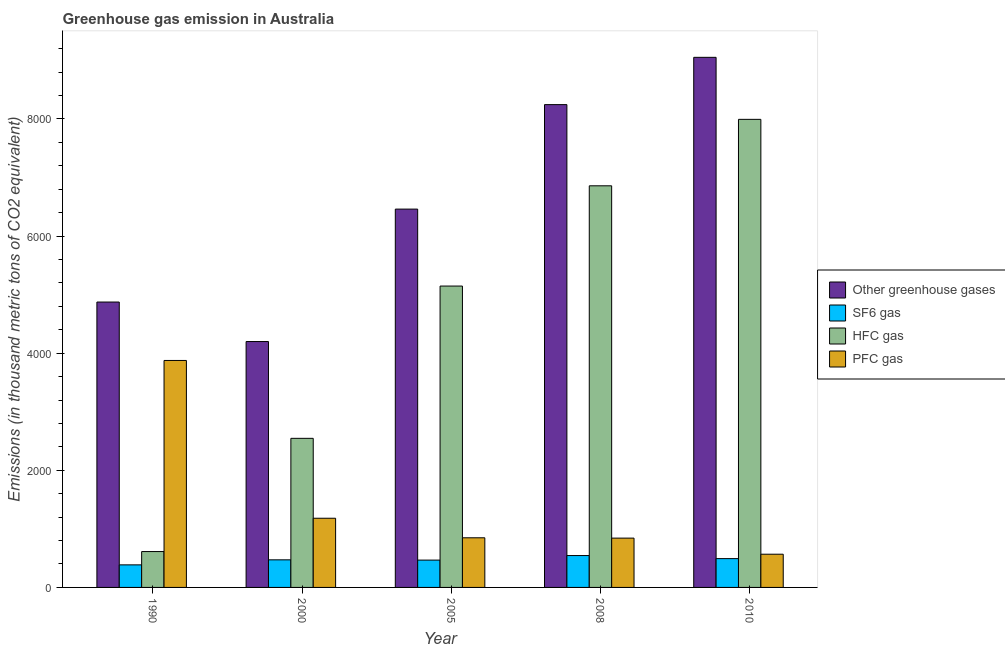How many different coloured bars are there?
Your response must be concise. 4. How many groups of bars are there?
Keep it short and to the point. 5. How many bars are there on the 2nd tick from the left?
Offer a terse response. 4. How many bars are there on the 5th tick from the right?
Your answer should be compact. 4. In how many cases, is the number of bars for a given year not equal to the number of legend labels?
Give a very brief answer. 0. What is the emission of pfc gas in 2008?
Offer a very short reply. 842. Across all years, what is the maximum emission of hfc gas?
Make the answer very short. 7992. Across all years, what is the minimum emission of hfc gas?
Your answer should be compact. 612.5. In which year was the emission of sf6 gas maximum?
Ensure brevity in your answer.  2008. In which year was the emission of sf6 gas minimum?
Provide a succinct answer. 1990. What is the total emission of sf6 gas in the graph?
Keep it short and to the point. 2359. What is the difference between the emission of pfc gas in 2005 and that in 2008?
Your answer should be compact. 5.4. What is the difference between the emission of hfc gas in 2008 and the emission of sf6 gas in 2010?
Your answer should be compact. -1134.6. What is the average emission of hfc gas per year?
Your response must be concise. 4630.64. In the year 2008, what is the difference between the emission of sf6 gas and emission of hfc gas?
Your response must be concise. 0. In how many years, is the emission of sf6 gas greater than 800 thousand metric tons?
Offer a terse response. 0. What is the ratio of the emission of sf6 gas in 1990 to that in 2008?
Give a very brief answer. 0.71. What is the difference between the highest and the second highest emission of sf6 gas?
Provide a succinct answer. 52.1. What is the difference between the highest and the lowest emission of hfc gas?
Make the answer very short. 7379.5. Is the sum of the emission of sf6 gas in 1990 and 2010 greater than the maximum emission of greenhouse gases across all years?
Your answer should be compact. Yes. What does the 4th bar from the left in 2000 represents?
Your response must be concise. PFC gas. What does the 3rd bar from the right in 2008 represents?
Provide a succinct answer. SF6 gas. How many years are there in the graph?
Offer a terse response. 5. What is the difference between two consecutive major ticks on the Y-axis?
Provide a short and direct response. 2000. Does the graph contain any zero values?
Give a very brief answer. No. Where does the legend appear in the graph?
Ensure brevity in your answer.  Center right. What is the title of the graph?
Keep it short and to the point. Greenhouse gas emission in Australia. Does "Taxes on exports" appear as one of the legend labels in the graph?
Provide a short and direct response. No. What is the label or title of the X-axis?
Ensure brevity in your answer.  Year. What is the label or title of the Y-axis?
Provide a short and direct response. Emissions (in thousand metric tons of CO2 equivalent). What is the Emissions (in thousand metric tons of CO2 equivalent) in Other greenhouse gases in 1990?
Keep it short and to the point. 4872.8. What is the Emissions (in thousand metric tons of CO2 equivalent) of SF6 gas in 1990?
Give a very brief answer. 385.1. What is the Emissions (in thousand metric tons of CO2 equivalent) of HFC gas in 1990?
Ensure brevity in your answer.  612.5. What is the Emissions (in thousand metric tons of CO2 equivalent) in PFC gas in 1990?
Provide a short and direct response. 3875.2. What is the Emissions (in thousand metric tons of CO2 equivalent) in Other greenhouse gases in 2000?
Offer a very short reply. 4198.3. What is the Emissions (in thousand metric tons of CO2 equivalent) in SF6 gas in 2000?
Provide a succinct answer. 471.2. What is the Emissions (in thousand metric tons of CO2 equivalent) of HFC gas in 2000?
Your answer should be compact. 2545.7. What is the Emissions (in thousand metric tons of CO2 equivalent) of PFC gas in 2000?
Provide a short and direct response. 1181.4. What is the Emissions (in thousand metric tons of CO2 equivalent) of Other greenhouse gases in 2005?
Provide a succinct answer. 6459.6. What is the Emissions (in thousand metric tons of CO2 equivalent) in SF6 gas in 2005?
Your answer should be very brief. 466.6. What is the Emissions (in thousand metric tons of CO2 equivalent) in HFC gas in 2005?
Ensure brevity in your answer.  5145.6. What is the Emissions (in thousand metric tons of CO2 equivalent) in PFC gas in 2005?
Your response must be concise. 847.4. What is the Emissions (in thousand metric tons of CO2 equivalent) in Other greenhouse gases in 2008?
Provide a short and direct response. 8243.5. What is the Emissions (in thousand metric tons of CO2 equivalent) in SF6 gas in 2008?
Make the answer very short. 544.1. What is the Emissions (in thousand metric tons of CO2 equivalent) in HFC gas in 2008?
Keep it short and to the point. 6857.4. What is the Emissions (in thousand metric tons of CO2 equivalent) in PFC gas in 2008?
Your answer should be very brief. 842. What is the Emissions (in thousand metric tons of CO2 equivalent) in Other greenhouse gases in 2010?
Your answer should be very brief. 9051. What is the Emissions (in thousand metric tons of CO2 equivalent) in SF6 gas in 2010?
Your answer should be compact. 492. What is the Emissions (in thousand metric tons of CO2 equivalent) of HFC gas in 2010?
Your answer should be very brief. 7992. What is the Emissions (in thousand metric tons of CO2 equivalent) of PFC gas in 2010?
Make the answer very short. 567. Across all years, what is the maximum Emissions (in thousand metric tons of CO2 equivalent) of Other greenhouse gases?
Make the answer very short. 9051. Across all years, what is the maximum Emissions (in thousand metric tons of CO2 equivalent) of SF6 gas?
Your answer should be compact. 544.1. Across all years, what is the maximum Emissions (in thousand metric tons of CO2 equivalent) of HFC gas?
Offer a terse response. 7992. Across all years, what is the maximum Emissions (in thousand metric tons of CO2 equivalent) of PFC gas?
Provide a succinct answer. 3875.2. Across all years, what is the minimum Emissions (in thousand metric tons of CO2 equivalent) in Other greenhouse gases?
Your response must be concise. 4198.3. Across all years, what is the minimum Emissions (in thousand metric tons of CO2 equivalent) in SF6 gas?
Offer a very short reply. 385.1. Across all years, what is the minimum Emissions (in thousand metric tons of CO2 equivalent) of HFC gas?
Provide a short and direct response. 612.5. Across all years, what is the minimum Emissions (in thousand metric tons of CO2 equivalent) in PFC gas?
Ensure brevity in your answer.  567. What is the total Emissions (in thousand metric tons of CO2 equivalent) of Other greenhouse gases in the graph?
Offer a terse response. 3.28e+04. What is the total Emissions (in thousand metric tons of CO2 equivalent) in SF6 gas in the graph?
Your response must be concise. 2359. What is the total Emissions (in thousand metric tons of CO2 equivalent) of HFC gas in the graph?
Provide a short and direct response. 2.32e+04. What is the total Emissions (in thousand metric tons of CO2 equivalent) in PFC gas in the graph?
Give a very brief answer. 7313. What is the difference between the Emissions (in thousand metric tons of CO2 equivalent) of Other greenhouse gases in 1990 and that in 2000?
Give a very brief answer. 674.5. What is the difference between the Emissions (in thousand metric tons of CO2 equivalent) of SF6 gas in 1990 and that in 2000?
Keep it short and to the point. -86.1. What is the difference between the Emissions (in thousand metric tons of CO2 equivalent) of HFC gas in 1990 and that in 2000?
Provide a short and direct response. -1933.2. What is the difference between the Emissions (in thousand metric tons of CO2 equivalent) in PFC gas in 1990 and that in 2000?
Provide a short and direct response. 2693.8. What is the difference between the Emissions (in thousand metric tons of CO2 equivalent) of Other greenhouse gases in 1990 and that in 2005?
Make the answer very short. -1586.8. What is the difference between the Emissions (in thousand metric tons of CO2 equivalent) in SF6 gas in 1990 and that in 2005?
Your response must be concise. -81.5. What is the difference between the Emissions (in thousand metric tons of CO2 equivalent) of HFC gas in 1990 and that in 2005?
Provide a short and direct response. -4533.1. What is the difference between the Emissions (in thousand metric tons of CO2 equivalent) of PFC gas in 1990 and that in 2005?
Provide a short and direct response. 3027.8. What is the difference between the Emissions (in thousand metric tons of CO2 equivalent) of Other greenhouse gases in 1990 and that in 2008?
Your answer should be very brief. -3370.7. What is the difference between the Emissions (in thousand metric tons of CO2 equivalent) in SF6 gas in 1990 and that in 2008?
Your answer should be very brief. -159. What is the difference between the Emissions (in thousand metric tons of CO2 equivalent) in HFC gas in 1990 and that in 2008?
Provide a succinct answer. -6244.9. What is the difference between the Emissions (in thousand metric tons of CO2 equivalent) in PFC gas in 1990 and that in 2008?
Make the answer very short. 3033.2. What is the difference between the Emissions (in thousand metric tons of CO2 equivalent) of Other greenhouse gases in 1990 and that in 2010?
Provide a short and direct response. -4178.2. What is the difference between the Emissions (in thousand metric tons of CO2 equivalent) in SF6 gas in 1990 and that in 2010?
Your answer should be very brief. -106.9. What is the difference between the Emissions (in thousand metric tons of CO2 equivalent) of HFC gas in 1990 and that in 2010?
Ensure brevity in your answer.  -7379.5. What is the difference between the Emissions (in thousand metric tons of CO2 equivalent) in PFC gas in 1990 and that in 2010?
Ensure brevity in your answer.  3308.2. What is the difference between the Emissions (in thousand metric tons of CO2 equivalent) of Other greenhouse gases in 2000 and that in 2005?
Give a very brief answer. -2261.3. What is the difference between the Emissions (in thousand metric tons of CO2 equivalent) in SF6 gas in 2000 and that in 2005?
Make the answer very short. 4.6. What is the difference between the Emissions (in thousand metric tons of CO2 equivalent) of HFC gas in 2000 and that in 2005?
Give a very brief answer. -2599.9. What is the difference between the Emissions (in thousand metric tons of CO2 equivalent) of PFC gas in 2000 and that in 2005?
Give a very brief answer. 334. What is the difference between the Emissions (in thousand metric tons of CO2 equivalent) of Other greenhouse gases in 2000 and that in 2008?
Your response must be concise. -4045.2. What is the difference between the Emissions (in thousand metric tons of CO2 equivalent) in SF6 gas in 2000 and that in 2008?
Make the answer very short. -72.9. What is the difference between the Emissions (in thousand metric tons of CO2 equivalent) in HFC gas in 2000 and that in 2008?
Ensure brevity in your answer.  -4311.7. What is the difference between the Emissions (in thousand metric tons of CO2 equivalent) of PFC gas in 2000 and that in 2008?
Provide a succinct answer. 339.4. What is the difference between the Emissions (in thousand metric tons of CO2 equivalent) in Other greenhouse gases in 2000 and that in 2010?
Provide a short and direct response. -4852.7. What is the difference between the Emissions (in thousand metric tons of CO2 equivalent) in SF6 gas in 2000 and that in 2010?
Your answer should be compact. -20.8. What is the difference between the Emissions (in thousand metric tons of CO2 equivalent) of HFC gas in 2000 and that in 2010?
Your answer should be compact. -5446.3. What is the difference between the Emissions (in thousand metric tons of CO2 equivalent) in PFC gas in 2000 and that in 2010?
Give a very brief answer. 614.4. What is the difference between the Emissions (in thousand metric tons of CO2 equivalent) in Other greenhouse gases in 2005 and that in 2008?
Offer a very short reply. -1783.9. What is the difference between the Emissions (in thousand metric tons of CO2 equivalent) of SF6 gas in 2005 and that in 2008?
Offer a terse response. -77.5. What is the difference between the Emissions (in thousand metric tons of CO2 equivalent) in HFC gas in 2005 and that in 2008?
Keep it short and to the point. -1711.8. What is the difference between the Emissions (in thousand metric tons of CO2 equivalent) in PFC gas in 2005 and that in 2008?
Keep it short and to the point. 5.4. What is the difference between the Emissions (in thousand metric tons of CO2 equivalent) of Other greenhouse gases in 2005 and that in 2010?
Your answer should be very brief. -2591.4. What is the difference between the Emissions (in thousand metric tons of CO2 equivalent) in SF6 gas in 2005 and that in 2010?
Keep it short and to the point. -25.4. What is the difference between the Emissions (in thousand metric tons of CO2 equivalent) in HFC gas in 2005 and that in 2010?
Provide a short and direct response. -2846.4. What is the difference between the Emissions (in thousand metric tons of CO2 equivalent) in PFC gas in 2005 and that in 2010?
Make the answer very short. 280.4. What is the difference between the Emissions (in thousand metric tons of CO2 equivalent) of Other greenhouse gases in 2008 and that in 2010?
Provide a short and direct response. -807.5. What is the difference between the Emissions (in thousand metric tons of CO2 equivalent) in SF6 gas in 2008 and that in 2010?
Offer a terse response. 52.1. What is the difference between the Emissions (in thousand metric tons of CO2 equivalent) in HFC gas in 2008 and that in 2010?
Provide a short and direct response. -1134.6. What is the difference between the Emissions (in thousand metric tons of CO2 equivalent) in PFC gas in 2008 and that in 2010?
Offer a terse response. 275. What is the difference between the Emissions (in thousand metric tons of CO2 equivalent) of Other greenhouse gases in 1990 and the Emissions (in thousand metric tons of CO2 equivalent) of SF6 gas in 2000?
Provide a short and direct response. 4401.6. What is the difference between the Emissions (in thousand metric tons of CO2 equivalent) in Other greenhouse gases in 1990 and the Emissions (in thousand metric tons of CO2 equivalent) in HFC gas in 2000?
Your response must be concise. 2327.1. What is the difference between the Emissions (in thousand metric tons of CO2 equivalent) in Other greenhouse gases in 1990 and the Emissions (in thousand metric tons of CO2 equivalent) in PFC gas in 2000?
Your answer should be compact. 3691.4. What is the difference between the Emissions (in thousand metric tons of CO2 equivalent) of SF6 gas in 1990 and the Emissions (in thousand metric tons of CO2 equivalent) of HFC gas in 2000?
Your answer should be very brief. -2160.6. What is the difference between the Emissions (in thousand metric tons of CO2 equivalent) in SF6 gas in 1990 and the Emissions (in thousand metric tons of CO2 equivalent) in PFC gas in 2000?
Ensure brevity in your answer.  -796.3. What is the difference between the Emissions (in thousand metric tons of CO2 equivalent) in HFC gas in 1990 and the Emissions (in thousand metric tons of CO2 equivalent) in PFC gas in 2000?
Your answer should be compact. -568.9. What is the difference between the Emissions (in thousand metric tons of CO2 equivalent) of Other greenhouse gases in 1990 and the Emissions (in thousand metric tons of CO2 equivalent) of SF6 gas in 2005?
Make the answer very short. 4406.2. What is the difference between the Emissions (in thousand metric tons of CO2 equivalent) in Other greenhouse gases in 1990 and the Emissions (in thousand metric tons of CO2 equivalent) in HFC gas in 2005?
Give a very brief answer. -272.8. What is the difference between the Emissions (in thousand metric tons of CO2 equivalent) in Other greenhouse gases in 1990 and the Emissions (in thousand metric tons of CO2 equivalent) in PFC gas in 2005?
Your answer should be very brief. 4025.4. What is the difference between the Emissions (in thousand metric tons of CO2 equivalent) of SF6 gas in 1990 and the Emissions (in thousand metric tons of CO2 equivalent) of HFC gas in 2005?
Give a very brief answer. -4760.5. What is the difference between the Emissions (in thousand metric tons of CO2 equivalent) in SF6 gas in 1990 and the Emissions (in thousand metric tons of CO2 equivalent) in PFC gas in 2005?
Ensure brevity in your answer.  -462.3. What is the difference between the Emissions (in thousand metric tons of CO2 equivalent) in HFC gas in 1990 and the Emissions (in thousand metric tons of CO2 equivalent) in PFC gas in 2005?
Offer a very short reply. -234.9. What is the difference between the Emissions (in thousand metric tons of CO2 equivalent) of Other greenhouse gases in 1990 and the Emissions (in thousand metric tons of CO2 equivalent) of SF6 gas in 2008?
Provide a succinct answer. 4328.7. What is the difference between the Emissions (in thousand metric tons of CO2 equivalent) of Other greenhouse gases in 1990 and the Emissions (in thousand metric tons of CO2 equivalent) of HFC gas in 2008?
Your response must be concise. -1984.6. What is the difference between the Emissions (in thousand metric tons of CO2 equivalent) of Other greenhouse gases in 1990 and the Emissions (in thousand metric tons of CO2 equivalent) of PFC gas in 2008?
Keep it short and to the point. 4030.8. What is the difference between the Emissions (in thousand metric tons of CO2 equivalent) of SF6 gas in 1990 and the Emissions (in thousand metric tons of CO2 equivalent) of HFC gas in 2008?
Your response must be concise. -6472.3. What is the difference between the Emissions (in thousand metric tons of CO2 equivalent) of SF6 gas in 1990 and the Emissions (in thousand metric tons of CO2 equivalent) of PFC gas in 2008?
Give a very brief answer. -456.9. What is the difference between the Emissions (in thousand metric tons of CO2 equivalent) of HFC gas in 1990 and the Emissions (in thousand metric tons of CO2 equivalent) of PFC gas in 2008?
Offer a terse response. -229.5. What is the difference between the Emissions (in thousand metric tons of CO2 equivalent) of Other greenhouse gases in 1990 and the Emissions (in thousand metric tons of CO2 equivalent) of SF6 gas in 2010?
Ensure brevity in your answer.  4380.8. What is the difference between the Emissions (in thousand metric tons of CO2 equivalent) of Other greenhouse gases in 1990 and the Emissions (in thousand metric tons of CO2 equivalent) of HFC gas in 2010?
Provide a short and direct response. -3119.2. What is the difference between the Emissions (in thousand metric tons of CO2 equivalent) in Other greenhouse gases in 1990 and the Emissions (in thousand metric tons of CO2 equivalent) in PFC gas in 2010?
Keep it short and to the point. 4305.8. What is the difference between the Emissions (in thousand metric tons of CO2 equivalent) in SF6 gas in 1990 and the Emissions (in thousand metric tons of CO2 equivalent) in HFC gas in 2010?
Provide a short and direct response. -7606.9. What is the difference between the Emissions (in thousand metric tons of CO2 equivalent) of SF6 gas in 1990 and the Emissions (in thousand metric tons of CO2 equivalent) of PFC gas in 2010?
Your response must be concise. -181.9. What is the difference between the Emissions (in thousand metric tons of CO2 equivalent) of HFC gas in 1990 and the Emissions (in thousand metric tons of CO2 equivalent) of PFC gas in 2010?
Your answer should be very brief. 45.5. What is the difference between the Emissions (in thousand metric tons of CO2 equivalent) of Other greenhouse gases in 2000 and the Emissions (in thousand metric tons of CO2 equivalent) of SF6 gas in 2005?
Give a very brief answer. 3731.7. What is the difference between the Emissions (in thousand metric tons of CO2 equivalent) of Other greenhouse gases in 2000 and the Emissions (in thousand metric tons of CO2 equivalent) of HFC gas in 2005?
Offer a terse response. -947.3. What is the difference between the Emissions (in thousand metric tons of CO2 equivalent) in Other greenhouse gases in 2000 and the Emissions (in thousand metric tons of CO2 equivalent) in PFC gas in 2005?
Make the answer very short. 3350.9. What is the difference between the Emissions (in thousand metric tons of CO2 equivalent) of SF6 gas in 2000 and the Emissions (in thousand metric tons of CO2 equivalent) of HFC gas in 2005?
Your answer should be compact. -4674.4. What is the difference between the Emissions (in thousand metric tons of CO2 equivalent) in SF6 gas in 2000 and the Emissions (in thousand metric tons of CO2 equivalent) in PFC gas in 2005?
Ensure brevity in your answer.  -376.2. What is the difference between the Emissions (in thousand metric tons of CO2 equivalent) of HFC gas in 2000 and the Emissions (in thousand metric tons of CO2 equivalent) of PFC gas in 2005?
Offer a terse response. 1698.3. What is the difference between the Emissions (in thousand metric tons of CO2 equivalent) in Other greenhouse gases in 2000 and the Emissions (in thousand metric tons of CO2 equivalent) in SF6 gas in 2008?
Offer a very short reply. 3654.2. What is the difference between the Emissions (in thousand metric tons of CO2 equivalent) in Other greenhouse gases in 2000 and the Emissions (in thousand metric tons of CO2 equivalent) in HFC gas in 2008?
Offer a terse response. -2659.1. What is the difference between the Emissions (in thousand metric tons of CO2 equivalent) in Other greenhouse gases in 2000 and the Emissions (in thousand metric tons of CO2 equivalent) in PFC gas in 2008?
Make the answer very short. 3356.3. What is the difference between the Emissions (in thousand metric tons of CO2 equivalent) in SF6 gas in 2000 and the Emissions (in thousand metric tons of CO2 equivalent) in HFC gas in 2008?
Make the answer very short. -6386.2. What is the difference between the Emissions (in thousand metric tons of CO2 equivalent) in SF6 gas in 2000 and the Emissions (in thousand metric tons of CO2 equivalent) in PFC gas in 2008?
Your response must be concise. -370.8. What is the difference between the Emissions (in thousand metric tons of CO2 equivalent) of HFC gas in 2000 and the Emissions (in thousand metric tons of CO2 equivalent) of PFC gas in 2008?
Your answer should be very brief. 1703.7. What is the difference between the Emissions (in thousand metric tons of CO2 equivalent) in Other greenhouse gases in 2000 and the Emissions (in thousand metric tons of CO2 equivalent) in SF6 gas in 2010?
Give a very brief answer. 3706.3. What is the difference between the Emissions (in thousand metric tons of CO2 equivalent) in Other greenhouse gases in 2000 and the Emissions (in thousand metric tons of CO2 equivalent) in HFC gas in 2010?
Ensure brevity in your answer.  -3793.7. What is the difference between the Emissions (in thousand metric tons of CO2 equivalent) of Other greenhouse gases in 2000 and the Emissions (in thousand metric tons of CO2 equivalent) of PFC gas in 2010?
Provide a succinct answer. 3631.3. What is the difference between the Emissions (in thousand metric tons of CO2 equivalent) in SF6 gas in 2000 and the Emissions (in thousand metric tons of CO2 equivalent) in HFC gas in 2010?
Your answer should be compact. -7520.8. What is the difference between the Emissions (in thousand metric tons of CO2 equivalent) in SF6 gas in 2000 and the Emissions (in thousand metric tons of CO2 equivalent) in PFC gas in 2010?
Offer a terse response. -95.8. What is the difference between the Emissions (in thousand metric tons of CO2 equivalent) in HFC gas in 2000 and the Emissions (in thousand metric tons of CO2 equivalent) in PFC gas in 2010?
Your answer should be very brief. 1978.7. What is the difference between the Emissions (in thousand metric tons of CO2 equivalent) of Other greenhouse gases in 2005 and the Emissions (in thousand metric tons of CO2 equivalent) of SF6 gas in 2008?
Provide a succinct answer. 5915.5. What is the difference between the Emissions (in thousand metric tons of CO2 equivalent) of Other greenhouse gases in 2005 and the Emissions (in thousand metric tons of CO2 equivalent) of HFC gas in 2008?
Provide a short and direct response. -397.8. What is the difference between the Emissions (in thousand metric tons of CO2 equivalent) in Other greenhouse gases in 2005 and the Emissions (in thousand metric tons of CO2 equivalent) in PFC gas in 2008?
Provide a succinct answer. 5617.6. What is the difference between the Emissions (in thousand metric tons of CO2 equivalent) in SF6 gas in 2005 and the Emissions (in thousand metric tons of CO2 equivalent) in HFC gas in 2008?
Provide a succinct answer. -6390.8. What is the difference between the Emissions (in thousand metric tons of CO2 equivalent) in SF6 gas in 2005 and the Emissions (in thousand metric tons of CO2 equivalent) in PFC gas in 2008?
Offer a terse response. -375.4. What is the difference between the Emissions (in thousand metric tons of CO2 equivalent) in HFC gas in 2005 and the Emissions (in thousand metric tons of CO2 equivalent) in PFC gas in 2008?
Make the answer very short. 4303.6. What is the difference between the Emissions (in thousand metric tons of CO2 equivalent) of Other greenhouse gases in 2005 and the Emissions (in thousand metric tons of CO2 equivalent) of SF6 gas in 2010?
Ensure brevity in your answer.  5967.6. What is the difference between the Emissions (in thousand metric tons of CO2 equivalent) in Other greenhouse gases in 2005 and the Emissions (in thousand metric tons of CO2 equivalent) in HFC gas in 2010?
Offer a very short reply. -1532.4. What is the difference between the Emissions (in thousand metric tons of CO2 equivalent) in Other greenhouse gases in 2005 and the Emissions (in thousand metric tons of CO2 equivalent) in PFC gas in 2010?
Give a very brief answer. 5892.6. What is the difference between the Emissions (in thousand metric tons of CO2 equivalent) in SF6 gas in 2005 and the Emissions (in thousand metric tons of CO2 equivalent) in HFC gas in 2010?
Make the answer very short. -7525.4. What is the difference between the Emissions (in thousand metric tons of CO2 equivalent) of SF6 gas in 2005 and the Emissions (in thousand metric tons of CO2 equivalent) of PFC gas in 2010?
Provide a succinct answer. -100.4. What is the difference between the Emissions (in thousand metric tons of CO2 equivalent) in HFC gas in 2005 and the Emissions (in thousand metric tons of CO2 equivalent) in PFC gas in 2010?
Offer a very short reply. 4578.6. What is the difference between the Emissions (in thousand metric tons of CO2 equivalent) of Other greenhouse gases in 2008 and the Emissions (in thousand metric tons of CO2 equivalent) of SF6 gas in 2010?
Your answer should be very brief. 7751.5. What is the difference between the Emissions (in thousand metric tons of CO2 equivalent) in Other greenhouse gases in 2008 and the Emissions (in thousand metric tons of CO2 equivalent) in HFC gas in 2010?
Offer a very short reply. 251.5. What is the difference between the Emissions (in thousand metric tons of CO2 equivalent) in Other greenhouse gases in 2008 and the Emissions (in thousand metric tons of CO2 equivalent) in PFC gas in 2010?
Keep it short and to the point. 7676.5. What is the difference between the Emissions (in thousand metric tons of CO2 equivalent) in SF6 gas in 2008 and the Emissions (in thousand metric tons of CO2 equivalent) in HFC gas in 2010?
Your answer should be compact. -7447.9. What is the difference between the Emissions (in thousand metric tons of CO2 equivalent) of SF6 gas in 2008 and the Emissions (in thousand metric tons of CO2 equivalent) of PFC gas in 2010?
Ensure brevity in your answer.  -22.9. What is the difference between the Emissions (in thousand metric tons of CO2 equivalent) in HFC gas in 2008 and the Emissions (in thousand metric tons of CO2 equivalent) in PFC gas in 2010?
Your answer should be compact. 6290.4. What is the average Emissions (in thousand metric tons of CO2 equivalent) in Other greenhouse gases per year?
Give a very brief answer. 6565.04. What is the average Emissions (in thousand metric tons of CO2 equivalent) of SF6 gas per year?
Give a very brief answer. 471.8. What is the average Emissions (in thousand metric tons of CO2 equivalent) of HFC gas per year?
Give a very brief answer. 4630.64. What is the average Emissions (in thousand metric tons of CO2 equivalent) of PFC gas per year?
Offer a very short reply. 1462.6. In the year 1990, what is the difference between the Emissions (in thousand metric tons of CO2 equivalent) of Other greenhouse gases and Emissions (in thousand metric tons of CO2 equivalent) of SF6 gas?
Offer a very short reply. 4487.7. In the year 1990, what is the difference between the Emissions (in thousand metric tons of CO2 equivalent) in Other greenhouse gases and Emissions (in thousand metric tons of CO2 equivalent) in HFC gas?
Give a very brief answer. 4260.3. In the year 1990, what is the difference between the Emissions (in thousand metric tons of CO2 equivalent) of Other greenhouse gases and Emissions (in thousand metric tons of CO2 equivalent) of PFC gas?
Offer a terse response. 997.6. In the year 1990, what is the difference between the Emissions (in thousand metric tons of CO2 equivalent) of SF6 gas and Emissions (in thousand metric tons of CO2 equivalent) of HFC gas?
Give a very brief answer. -227.4. In the year 1990, what is the difference between the Emissions (in thousand metric tons of CO2 equivalent) in SF6 gas and Emissions (in thousand metric tons of CO2 equivalent) in PFC gas?
Ensure brevity in your answer.  -3490.1. In the year 1990, what is the difference between the Emissions (in thousand metric tons of CO2 equivalent) of HFC gas and Emissions (in thousand metric tons of CO2 equivalent) of PFC gas?
Provide a short and direct response. -3262.7. In the year 2000, what is the difference between the Emissions (in thousand metric tons of CO2 equivalent) in Other greenhouse gases and Emissions (in thousand metric tons of CO2 equivalent) in SF6 gas?
Keep it short and to the point. 3727.1. In the year 2000, what is the difference between the Emissions (in thousand metric tons of CO2 equivalent) of Other greenhouse gases and Emissions (in thousand metric tons of CO2 equivalent) of HFC gas?
Provide a short and direct response. 1652.6. In the year 2000, what is the difference between the Emissions (in thousand metric tons of CO2 equivalent) of Other greenhouse gases and Emissions (in thousand metric tons of CO2 equivalent) of PFC gas?
Make the answer very short. 3016.9. In the year 2000, what is the difference between the Emissions (in thousand metric tons of CO2 equivalent) of SF6 gas and Emissions (in thousand metric tons of CO2 equivalent) of HFC gas?
Offer a very short reply. -2074.5. In the year 2000, what is the difference between the Emissions (in thousand metric tons of CO2 equivalent) in SF6 gas and Emissions (in thousand metric tons of CO2 equivalent) in PFC gas?
Your answer should be very brief. -710.2. In the year 2000, what is the difference between the Emissions (in thousand metric tons of CO2 equivalent) of HFC gas and Emissions (in thousand metric tons of CO2 equivalent) of PFC gas?
Offer a very short reply. 1364.3. In the year 2005, what is the difference between the Emissions (in thousand metric tons of CO2 equivalent) in Other greenhouse gases and Emissions (in thousand metric tons of CO2 equivalent) in SF6 gas?
Provide a short and direct response. 5993. In the year 2005, what is the difference between the Emissions (in thousand metric tons of CO2 equivalent) in Other greenhouse gases and Emissions (in thousand metric tons of CO2 equivalent) in HFC gas?
Keep it short and to the point. 1314. In the year 2005, what is the difference between the Emissions (in thousand metric tons of CO2 equivalent) in Other greenhouse gases and Emissions (in thousand metric tons of CO2 equivalent) in PFC gas?
Provide a short and direct response. 5612.2. In the year 2005, what is the difference between the Emissions (in thousand metric tons of CO2 equivalent) in SF6 gas and Emissions (in thousand metric tons of CO2 equivalent) in HFC gas?
Offer a terse response. -4679. In the year 2005, what is the difference between the Emissions (in thousand metric tons of CO2 equivalent) in SF6 gas and Emissions (in thousand metric tons of CO2 equivalent) in PFC gas?
Offer a very short reply. -380.8. In the year 2005, what is the difference between the Emissions (in thousand metric tons of CO2 equivalent) in HFC gas and Emissions (in thousand metric tons of CO2 equivalent) in PFC gas?
Ensure brevity in your answer.  4298.2. In the year 2008, what is the difference between the Emissions (in thousand metric tons of CO2 equivalent) of Other greenhouse gases and Emissions (in thousand metric tons of CO2 equivalent) of SF6 gas?
Ensure brevity in your answer.  7699.4. In the year 2008, what is the difference between the Emissions (in thousand metric tons of CO2 equivalent) of Other greenhouse gases and Emissions (in thousand metric tons of CO2 equivalent) of HFC gas?
Offer a terse response. 1386.1. In the year 2008, what is the difference between the Emissions (in thousand metric tons of CO2 equivalent) in Other greenhouse gases and Emissions (in thousand metric tons of CO2 equivalent) in PFC gas?
Offer a terse response. 7401.5. In the year 2008, what is the difference between the Emissions (in thousand metric tons of CO2 equivalent) of SF6 gas and Emissions (in thousand metric tons of CO2 equivalent) of HFC gas?
Ensure brevity in your answer.  -6313.3. In the year 2008, what is the difference between the Emissions (in thousand metric tons of CO2 equivalent) of SF6 gas and Emissions (in thousand metric tons of CO2 equivalent) of PFC gas?
Give a very brief answer. -297.9. In the year 2008, what is the difference between the Emissions (in thousand metric tons of CO2 equivalent) of HFC gas and Emissions (in thousand metric tons of CO2 equivalent) of PFC gas?
Give a very brief answer. 6015.4. In the year 2010, what is the difference between the Emissions (in thousand metric tons of CO2 equivalent) of Other greenhouse gases and Emissions (in thousand metric tons of CO2 equivalent) of SF6 gas?
Keep it short and to the point. 8559. In the year 2010, what is the difference between the Emissions (in thousand metric tons of CO2 equivalent) in Other greenhouse gases and Emissions (in thousand metric tons of CO2 equivalent) in HFC gas?
Provide a succinct answer. 1059. In the year 2010, what is the difference between the Emissions (in thousand metric tons of CO2 equivalent) of Other greenhouse gases and Emissions (in thousand metric tons of CO2 equivalent) of PFC gas?
Offer a terse response. 8484. In the year 2010, what is the difference between the Emissions (in thousand metric tons of CO2 equivalent) of SF6 gas and Emissions (in thousand metric tons of CO2 equivalent) of HFC gas?
Offer a very short reply. -7500. In the year 2010, what is the difference between the Emissions (in thousand metric tons of CO2 equivalent) of SF6 gas and Emissions (in thousand metric tons of CO2 equivalent) of PFC gas?
Ensure brevity in your answer.  -75. In the year 2010, what is the difference between the Emissions (in thousand metric tons of CO2 equivalent) of HFC gas and Emissions (in thousand metric tons of CO2 equivalent) of PFC gas?
Offer a terse response. 7425. What is the ratio of the Emissions (in thousand metric tons of CO2 equivalent) of Other greenhouse gases in 1990 to that in 2000?
Make the answer very short. 1.16. What is the ratio of the Emissions (in thousand metric tons of CO2 equivalent) in SF6 gas in 1990 to that in 2000?
Your answer should be very brief. 0.82. What is the ratio of the Emissions (in thousand metric tons of CO2 equivalent) in HFC gas in 1990 to that in 2000?
Your response must be concise. 0.24. What is the ratio of the Emissions (in thousand metric tons of CO2 equivalent) in PFC gas in 1990 to that in 2000?
Ensure brevity in your answer.  3.28. What is the ratio of the Emissions (in thousand metric tons of CO2 equivalent) of Other greenhouse gases in 1990 to that in 2005?
Ensure brevity in your answer.  0.75. What is the ratio of the Emissions (in thousand metric tons of CO2 equivalent) in SF6 gas in 1990 to that in 2005?
Make the answer very short. 0.83. What is the ratio of the Emissions (in thousand metric tons of CO2 equivalent) in HFC gas in 1990 to that in 2005?
Your response must be concise. 0.12. What is the ratio of the Emissions (in thousand metric tons of CO2 equivalent) of PFC gas in 1990 to that in 2005?
Your answer should be very brief. 4.57. What is the ratio of the Emissions (in thousand metric tons of CO2 equivalent) in Other greenhouse gases in 1990 to that in 2008?
Keep it short and to the point. 0.59. What is the ratio of the Emissions (in thousand metric tons of CO2 equivalent) of SF6 gas in 1990 to that in 2008?
Offer a terse response. 0.71. What is the ratio of the Emissions (in thousand metric tons of CO2 equivalent) in HFC gas in 1990 to that in 2008?
Your response must be concise. 0.09. What is the ratio of the Emissions (in thousand metric tons of CO2 equivalent) of PFC gas in 1990 to that in 2008?
Offer a very short reply. 4.6. What is the ratio of the Emissions (in thousand metric tons of CO2 equivalent) in Other greenhouse gases in 1990 to that in 2010?
Your answer should be compact. 0.54. What is the ratio of the Emissions (in thousand metric tons of CO2 equivalent) of SF6 gas in 1990 to that in 2010?
Make the answer very short. 0.78. What is the ratio of the Emissions (in thousand metric tons of CO2 equivalent) in HFC gas in 1990 to that in 2010?
Offer a very short reply. 0.08. What is the ratio of the Emissions (in thousand metric tons of CO2 equivalent) of PFC gas in 1990 to that in 2010?
Give a very brief answer. 6.83. What is the ratio of the Emissions (in thousand metric tons of CO2 equivalent) in Other greenhouse gases in 2000 to that in 2005?
Make the answer very short. 0.65. What is the ratio of the Emissions (in thousand metric tons of CO2 equivalent) in SF6 gas in 2000 to that in 2005?
Your answer should be compact. 1.01. What is the ratio of the Emissions (in thousand metric tons of CO2 equivalent) of HFC gas in 2000 to that in 2005?
Provide a short and direct response. 0.49. What is the ratio of the Emissions (in thousand metric tons of CO2 equivalent) in PFC gas in 2000 to that in 2005?
Ensure brevity in your answer.  1.39. What is the ratio of the Emissions (in thousand metric tons of CO2 equivalent) of Other greenhouse gases in 2000 to that in 2008?
Provide a succinct answer. 0.51. What is the ratio of the Emissions (in thousand metric tons of CO2 equivalent) of SF6 gas in 2000 to that in 2008?
Your answer should be very brief. 0.87. What is the ratio of the Emissions (in thousand metric tons of CO2 equivalent) of HFC gas in 2000 to that in 2008?
Your response must be concise. 0.37. What is the ratio of the Emissions (in thousand metric tons of CO2 equivalent) in PFC gas in 2000 to that in 2008?
Your response must be concise. 1.4. What is the ratio of the Emissions (in thousand metric tons of CO2 equivalent) of Other greenhouse gases in 2000 to that in 2010?
Keep it short and to the point. 0.46. What is the ratio of the Emissions (in thousand metric tons of CO2 equivalent) of SF6 gas in 2000 to that in 2010?
Offer a terse response. 0.96. What is the ratio of the Emissions (in thousand metric tons of CO2 equivalent) of HFC gas in 2000 to that in 2010?
Make the answer very short. 0.32. What is the ratio of the Emissions (in thousand metric tons of CO2 equivalent) of PFC gas in 2000 to that in 2010?
Give a very brief answer. 2.08. What is the ratio of the Emissions (in thousand metric tons of CO2 equivalent) in Other greenhouse gases in 2005 to that in 2008?
Ensure brevity in your answer.  0.78. What is the ratio of the Emissions (in thousand metric tons of CO2 equivalent) of SF6 gas in 2005 to that in 2008?
Make the answer very short. 0.86. What is the ratio of the Emissions (in thousand metric tons of CO2 equivalent) of HFC gas in 2005 to that in 2008?
Your response must be concise. 0.75. What is the ratio of the Emissions (in thousand metric tons of CO2 equivalent) of PFC gas in 2005 to that in 2008?
Your answer should be very brief. 1.01. What is the ratio of the Emissions (in thousand metric tons of CO2 equivalent) of Other greenhouse gases in 2005 to that in 2010?
Provide a short and direct response. 0.71. What is the ratio of the Emissions (in thousand metric tons of CO2 equivalent) in SF6 gas in 2005 to that in 2010?
Keep it short and to the point. 0.95. What is the ratio of the Emissions (in thousand metric tons of CO2 equivalent) of HFC gas in 2005 to that in 2010?
Ensure brevity in your answer.  0.64. What is the ratio of the Emissions (in thousand metric tons of CO2 equivalent) of PFC gas in 2005 to that in 2010?
Your answer should be very brief. 1.49. What is the ratio of the Emissions (in thousand metric tons of CO2 equivalent) of Other greenhouse gases in 2008 to that in 2010?
Your answer should be very brief. 0.91. What is the ratio of the Emissions (in thousand metric tons of CO2 equivalent) of SF6 gas in 2008 to that in 2010?
Your answer should be compact. 1.11. What is the ratio of the Emissions (in thousand metric tons of CO2 equivalent) of HFC gas in 2008 to that in 2010?
Provide a short and direct response. 0.86. What is the ratio of the Emissions (in thousand metric tons of CO2 equivalent) of PFC gas in 2008 to that in 2010?
Your answer should be very brief. 1.49. What is the difference between the highest and the second highest Emissions (in thousand metric tons of CO2 equivalent) in Other greenhouse gases?
Provide a succinct answer. 807.5. What is the difference between the highest and the second highest Emissions (in thousand metric tons of CO2 equivalent) of SF6 gas?
Make the answer very short. 52.1. What is the difference between the highest and the second highest Emissions (in thousand metric tons of CO2 equivalent) in HFC gas?
Make the answer very short. 1134.6. What is the difference between the highest and the second highest Emissions (in thousand metric tons of CO2 equivalent) of PFC gas?
Your response must be concise. 2693.8. What is the difference between the highest and the lowest Emissions (in thousand metric tons of CO2 equivalent) of Other greenhouse gases?
Keep it short and to the point. 4852.7. What is the difference between the highest and the lowest Emissions (in thousand metric tons of CO2 equivalent) of SF6 gas?
Your answer should be very brief. 159. What is the difference between the highest and the lowest Emissions (in thousand metric tons of CO2 equivalent) in HFC gas?
Offer a terse response. 7379.5. What is the difference between the highest and the lowest Emissions (in thousand metric tons of CO2 equivalent) of PFC gas?
Make the answer very short. 3308.2. 